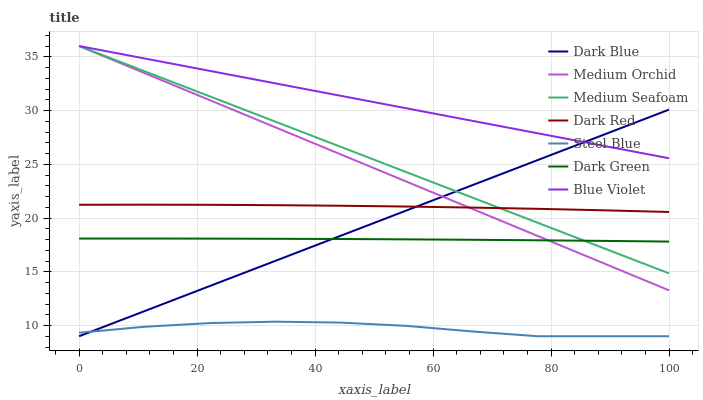Does Steel Blue have the minimum area under the curve?
Answer yes or no. Yes. Does Blue Violet have the maximum area under the curve?
Answer yes or no. Yes. Does Medium Orchid have the minimum area under the curve?
Answer yes or no. No. Does Medium Orchid have the maximum area under the curve?
Answer yes or no. No. Is Blue Violet the smoothest?
Answer yes or no. Yes. Is Steel Blue the roughest?
Answer yes or no. Yes. Is Medium Orchid the smoothest?
Answer yes or no. No. Is Medium Orchid the roughest?
Answer yes or no. No. Does Steel Blue have the lowest value?
Answer yes or no. Yes. Does Medium Orchid have the lowest value?
Answer yes or no. No. Does Blue Violet have the highest value?
Answer yes or no. Yes. Does Steel Blue have the highest value?
Answer yes or no. No. Is Steel Blue less than Dark Red?
Answer yes or no. Yes. Is Dark Red greater than Dark Green?
Answer yes or no. Yes. Does Dark Red intersect Medium Seafoam?
Answer yes or no. Yes. Is Dark Red less than Medium Seafoam?
Answer yes or no. No. Is Dark Red greater than Medium Seafoam?
Answer yes or no. No. Does Steel Blue intersect Dark Red?
Answer yes or no. No. 